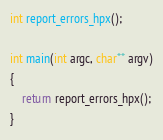Convert code to text. <code><loc_0><loc_0><loc_500><loc_500><_C++_>int report_errors_hpx();

int main(int argc, char** argv)
{
    return report_errors_hpx();
}
</code> 